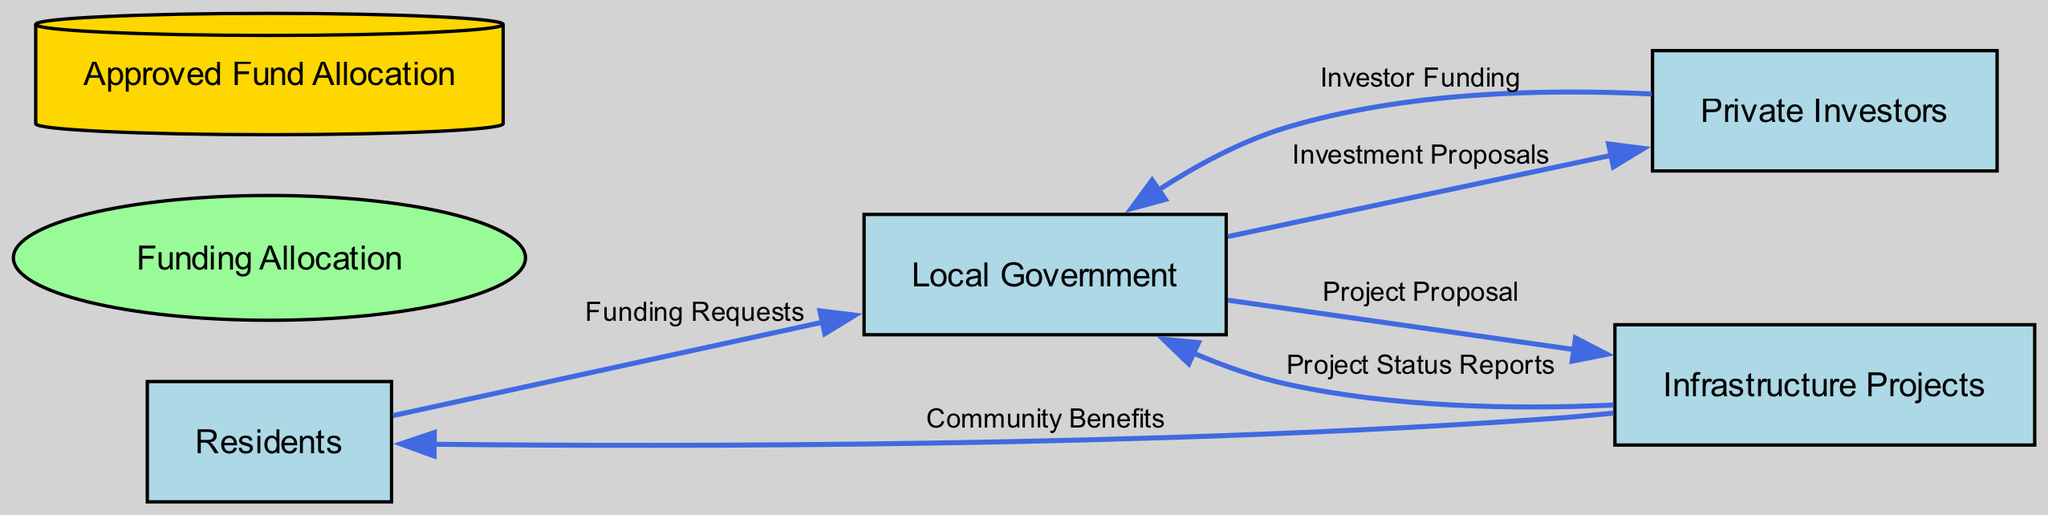How many entities are there in the diagram? The diagram contains entities such as Residents, Local Government, Infrastructure Projects, and Private Investors. By counting these unique entities, there are four identified: Residents, Local Government, Infrastructure Projects, and Private Investors.
Answer: 4 What flows from Residents to Local Government? The diagram indicates that "Funding Requests" flow from Residents to Local Government, representing the requests for funding submitted by residents and local businesses for public infrastructure projects.
Answer: Funding Requests Which process is responsible for evaluating funding? The "Funding Allocation" process is responsible for evaluating and distributing funds to various public infrastructure projects as indicated in the diagram.
Answer: Funding Allocation What is stored as "Approved Fund Allocation"? The "Approved Fund Allocation" is a data store that holds the distributions of funds that have been approved by the local government for various public infrastructure projects.
Answer: Fund distributions approved What do the Infrastructure Projects provide to Residents? The Infrastructure Projects provide "Community Benefits", which are improved public services and facilities that ultimately benefit the residents in the community.
Answer: Community Benefits How do private investors contribute to funding? Private investors contribute to funding by providing "Investor Funding", which is the money they invest in the infrastructure projects as shown in the flow from Private Investors to Local Government.
Answer: Investor Funding What proposal comes from the Local Government to Infrastructure Projects? The Local Government provides a "Project Proposal" to the Infrastructure Projects, detailing new infrastructure projects that may be undertaken in the community.
Answer: Project Proposal What report is sent from Infrastructure Projects to Local Government? "Project Status Reports" are sent from the Infrastructure Projects to the Local Government, providing updates on the status of ongoing public infrastructure projects.
Answer: Project Status Reports What type of diagram is represented in this visualization? The diagram type represented in this visualization is a Data Flow Diagram, which illustrates the flow of data and processes among the various entities within the context of community investment in public infrastructure.
Answer: Data Flow Diagram 